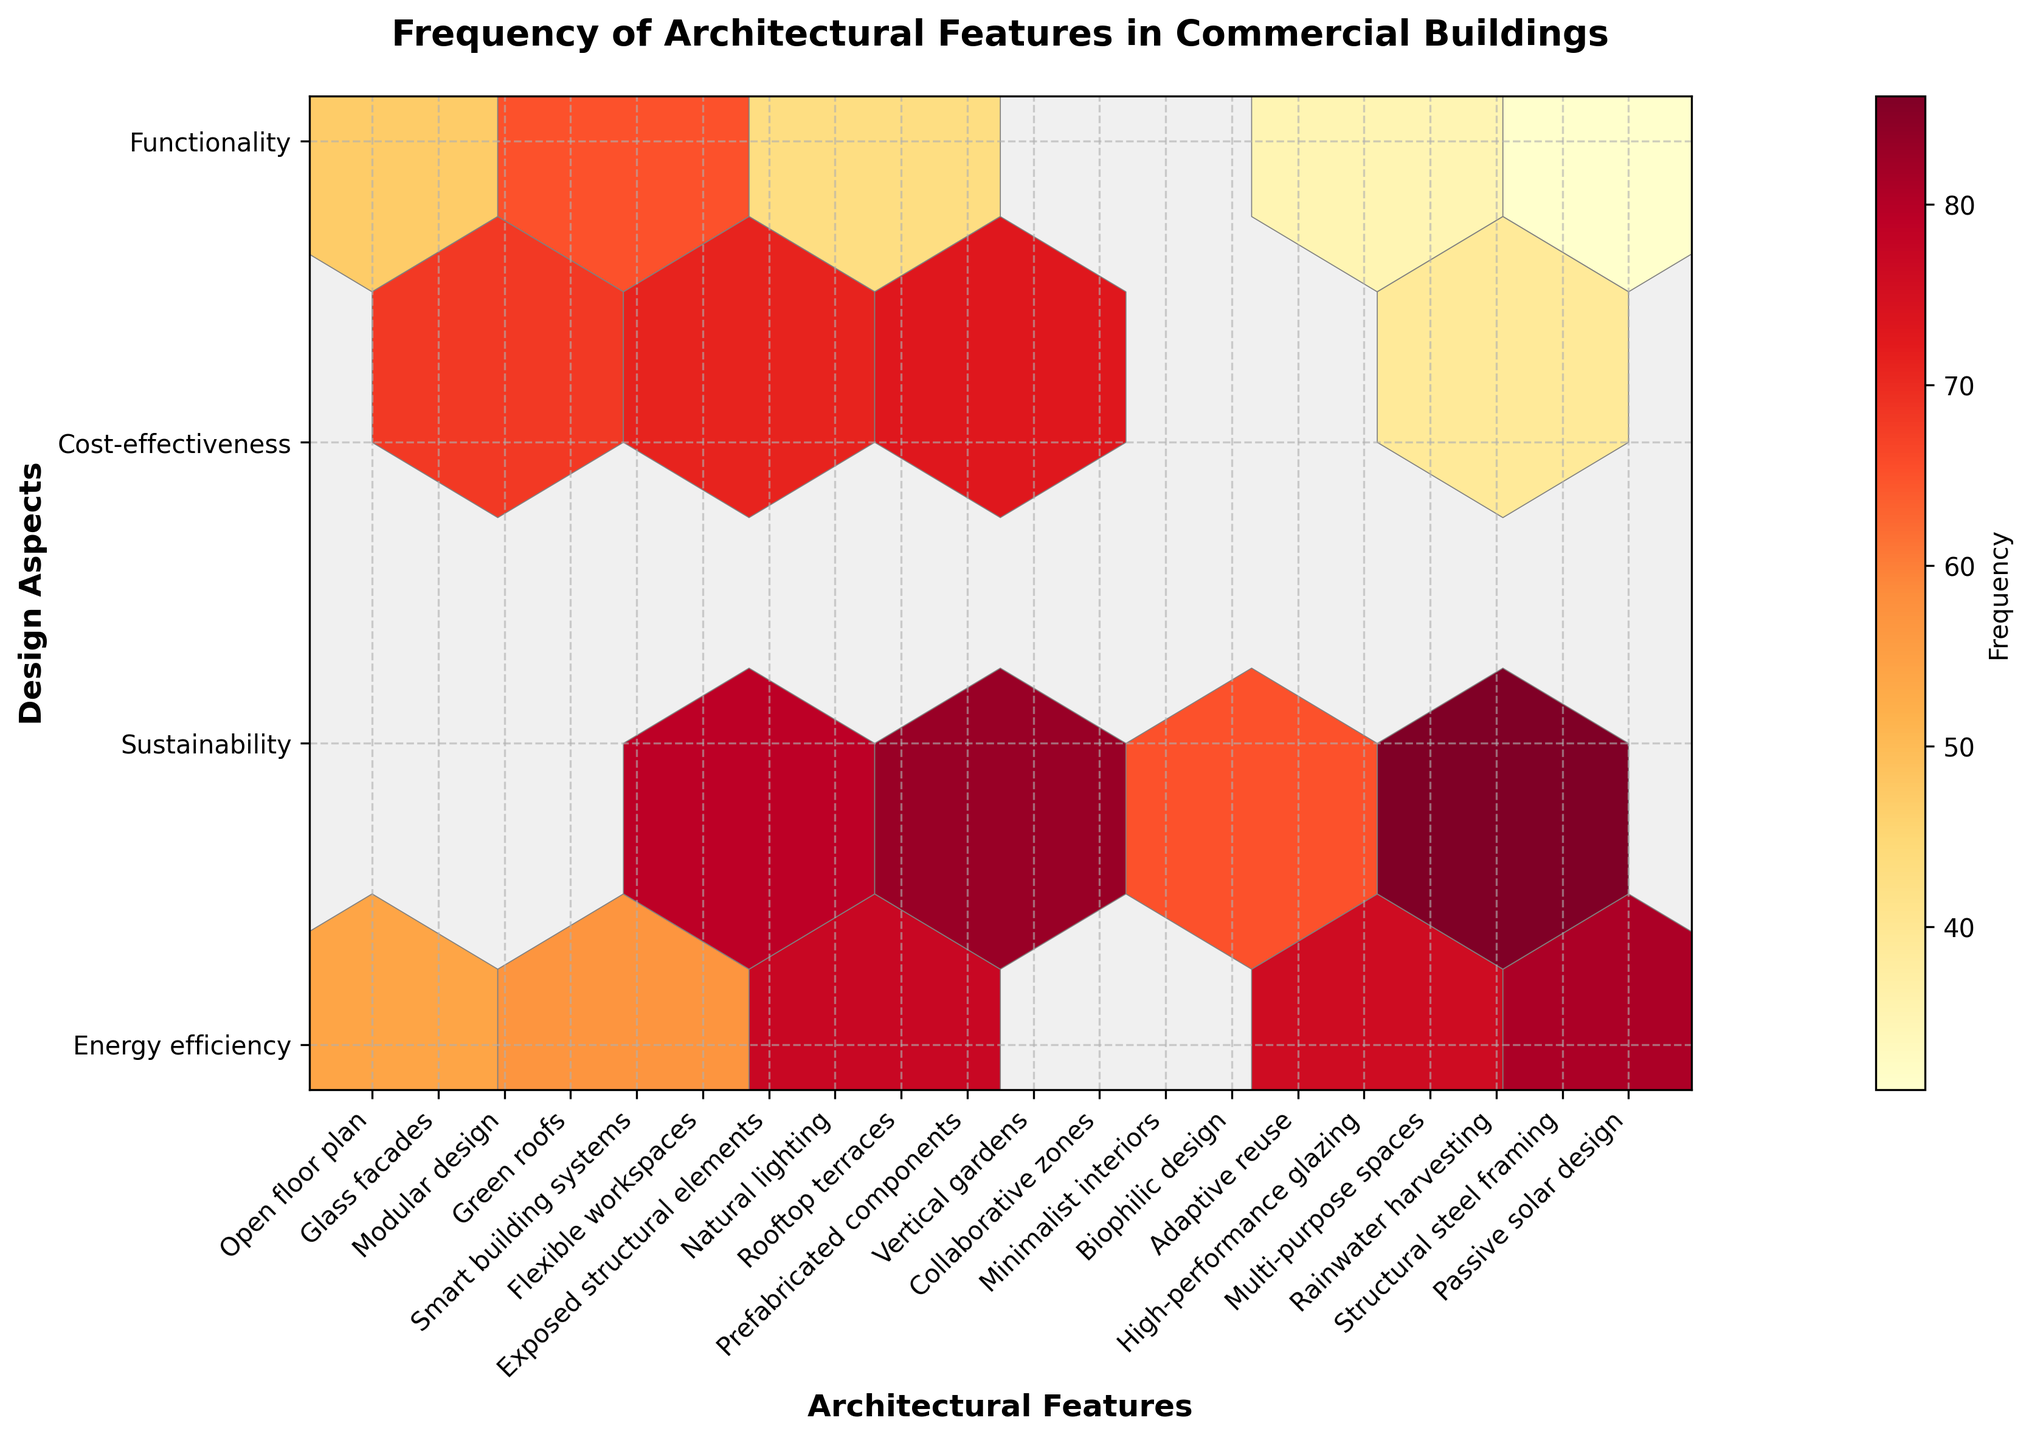what is the title of the figure? The title of a hexbin plot is usually displayed at the top center of the plot. In this case, the title is displayed in bold font.
Answer: Frequency of Architectural Features in Commercial Buildings What are the axes labels in the figure? The labels of the axes specify what each axis represents. The x-axis is labeled "Architectural Features" and the y-axis is labeled "Design Aspects."
Answer: Architectural Features and Design Aspects Which architectural features are most associated with cost-effectiveness? You need to find the "cost-effectiveness" on the y-axis and then look at the corresponding x-axis values where white-to-orange hexagons (highest frequencies) are present. These will indicate features associated with cost-effectiveness.
Answer: Modular design, Exposed structural elements, Prefabricated components, Minimalist interiors, and Adaptive reuse What design aspect has the highest frequency in the plot? The color of the hexagons reflects their frequency, with deeper colors indicating higher frequencies. Identify the design aspect that aligns with the deepest hue.
Answer: Energy efficiency How many design trends are clustered around smart building systems? Locate the point corresponding to "Smart building systems" on the x-axis and check its neighboring hexagons to see how many distinct clusters are around it.
Answer: Three clusters Which architectural feature appears to have the lowest association with functionality? Look at the functionalities on the y-axis and find the x-axis value with the lightest hexagon (lowest frequency).
Answer: Rooftop terraces Which architectural feature related to sustainability has a notably high frequency? Observe the hexagons aligned with "sustainability" on the y-axis and locate the deepest colored hexagon to determine the related architectural feature.
Answer: Glass facades Which design aspect has the lowest number of architectural features with frequencies displayed? Count the number of different architectural features on the x-axis corresponding to each design aspect on the y-axis and identify the aspect with the fewest features.
Answer: Sustainability Comparing green roofs and biophilic design, which has a higher frequency in sustainability? Locate the positions of "Green roofs" and "Biophilic design" along the x-axis, within the "Sustainability" section of the y-axis, and compare their respective colors.
Answer: Green roofs What is the average frequency of all modular design features in cost-effectiveness? Add the frequencies of modular design in the cost-effectiveness category and divide by the number of occurrences to find the average.
Answer: 92 